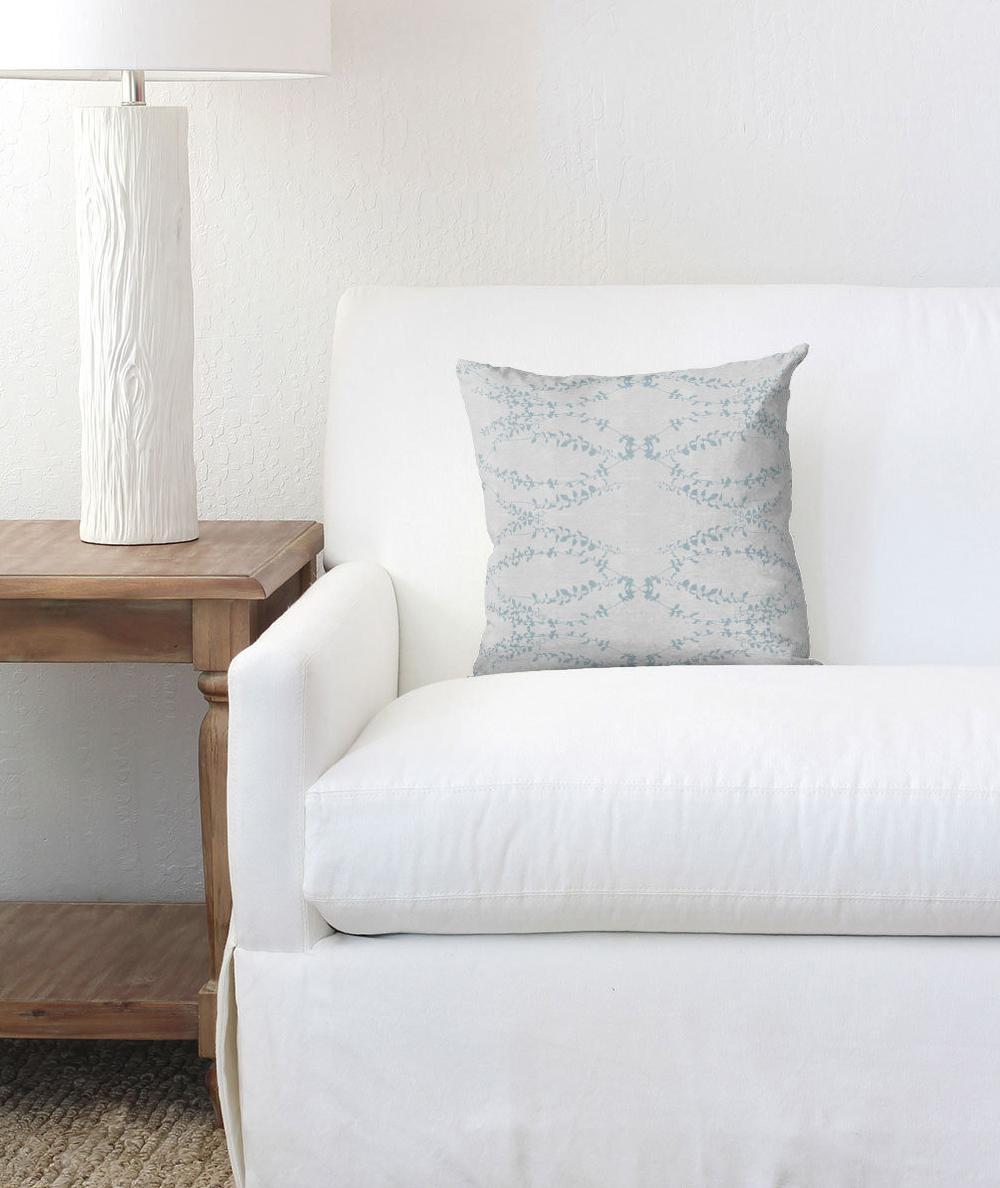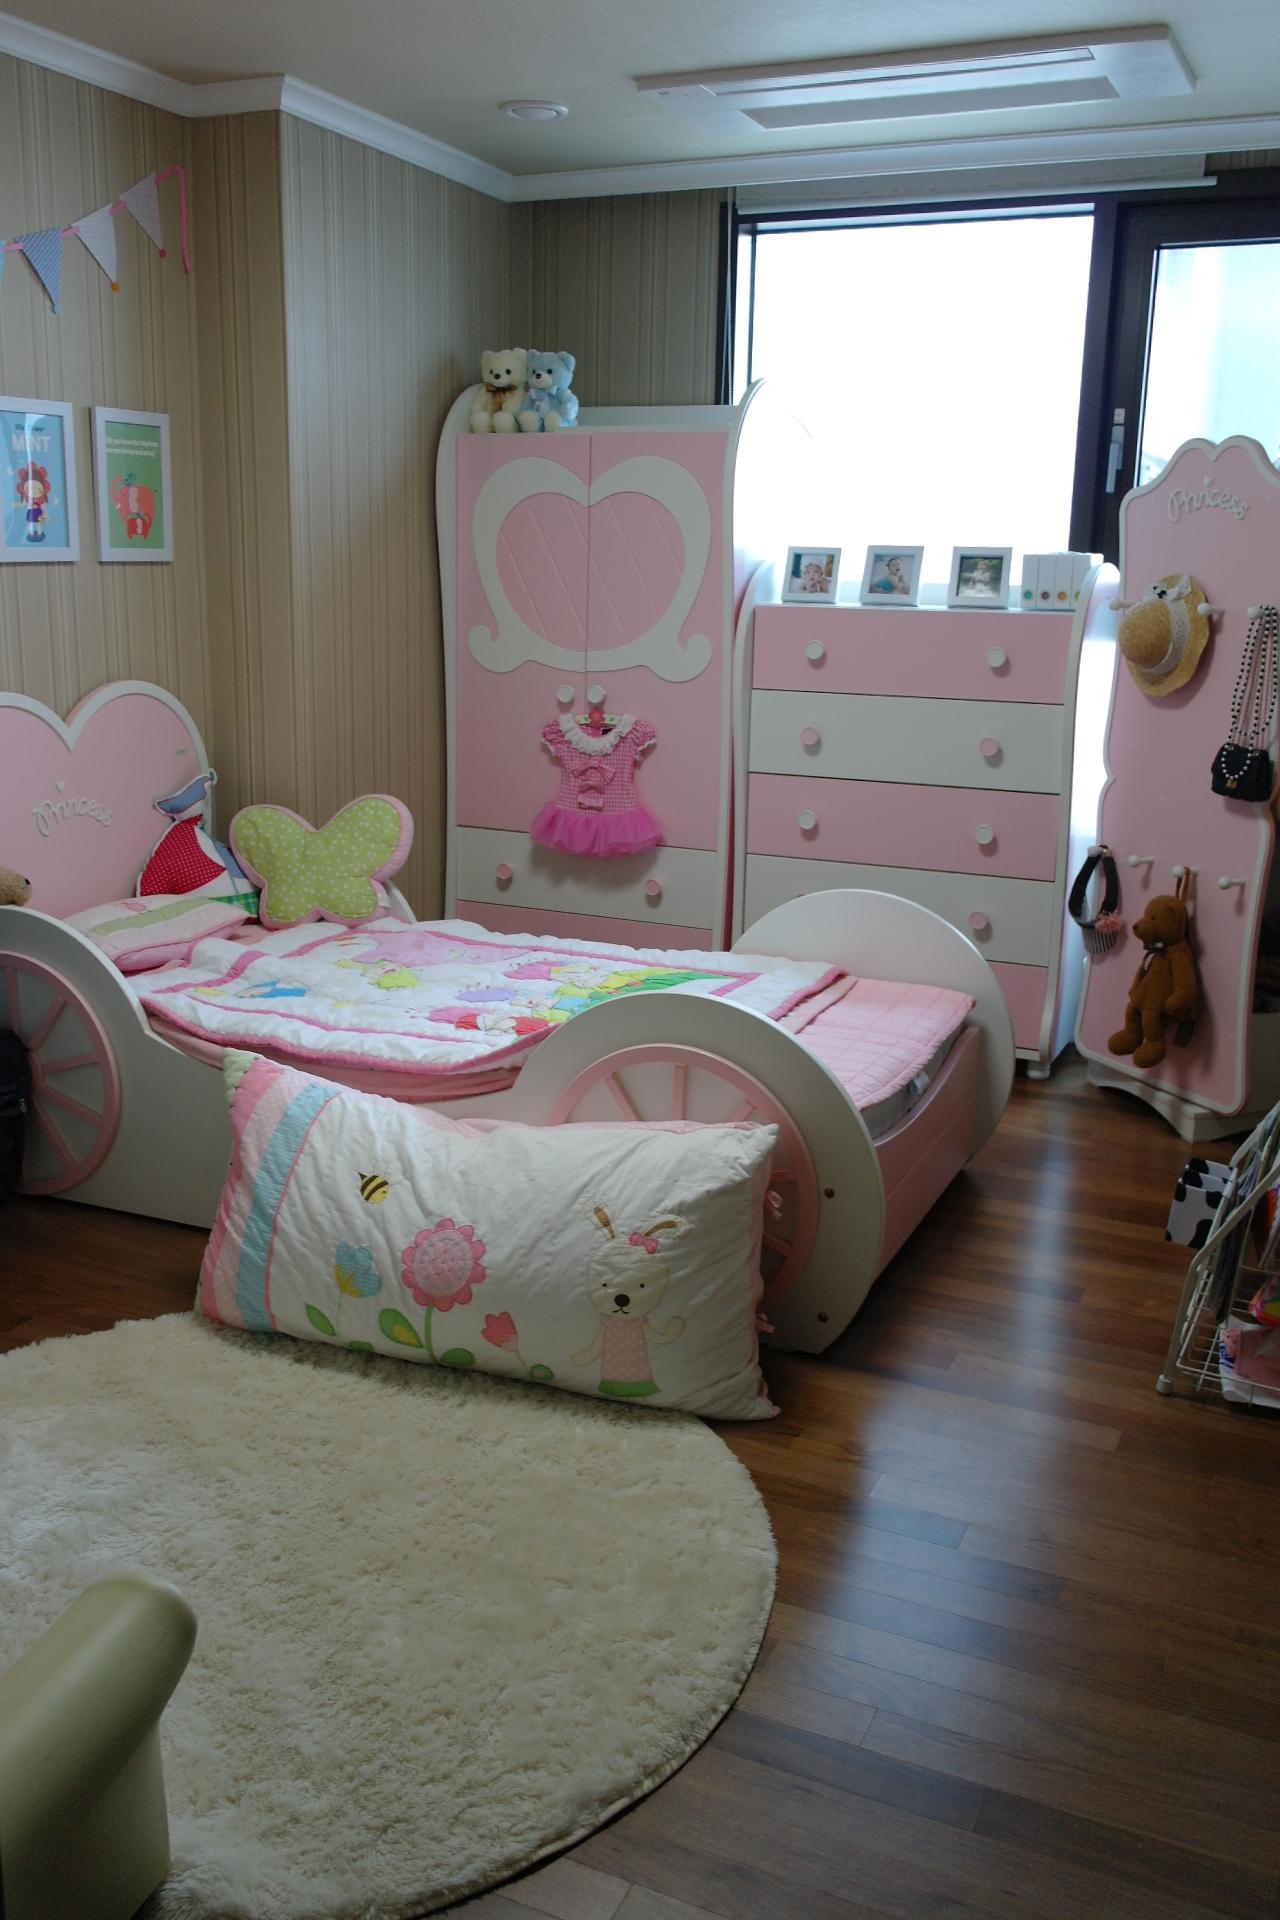The first image is the image on the left, the second image is the image on the right. Evaluate the accuracy of this statement regarding the images: "An image shows a bed that features a round design element.". Is it true? Answer yes or no. Yes. 